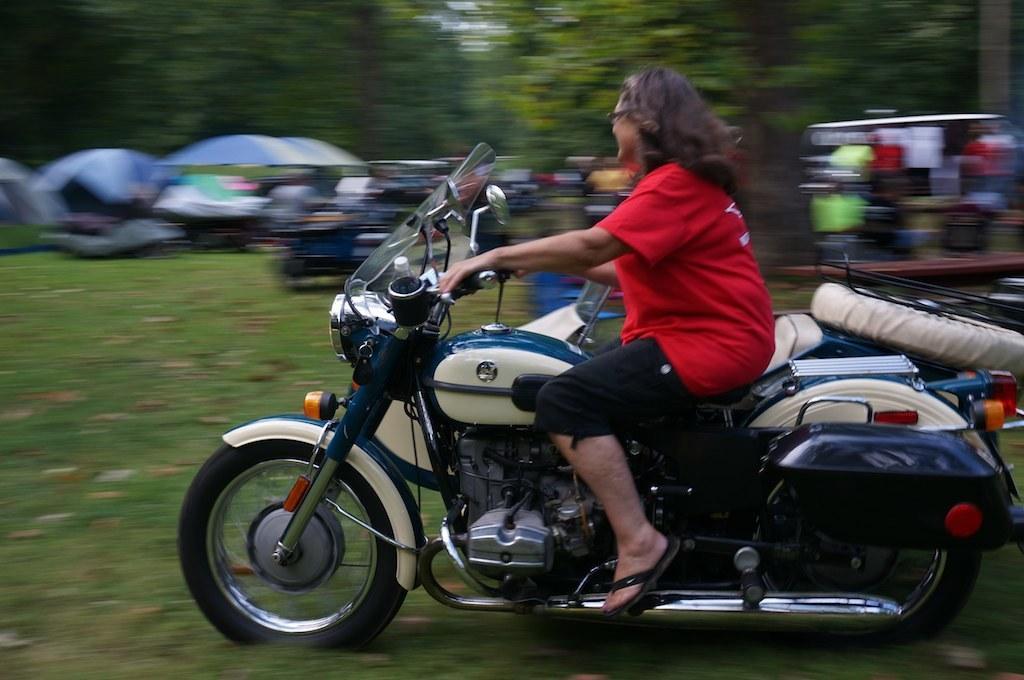Could you give a brief overview of what you see in this image? In this image I can see a person is sitting on a bike. I can see few trees in the background. 